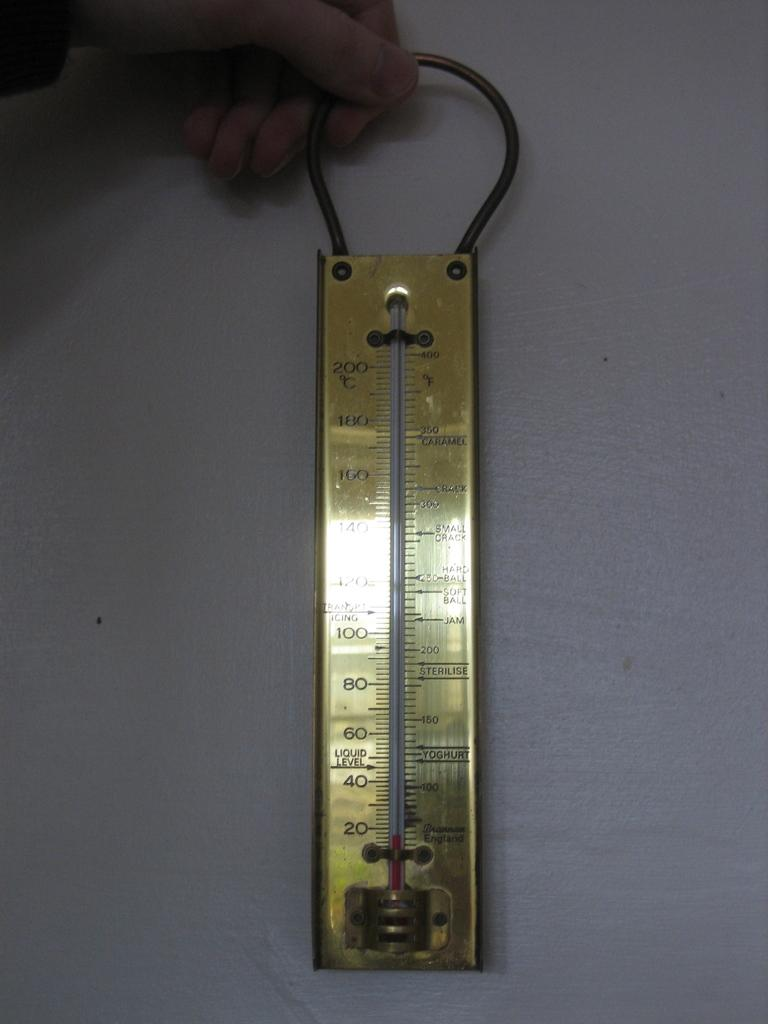Who or what is the main subject in the image? There is a person in the image. What is the person holding in the image? The person is holding a golden color ruler. What color is the background of the image? The background of the image is white. What type of birthday celebration is depicted in the image? There is no indication of a birthday celebration in the image; it only features a person holding a golden color ruler against a white background. 